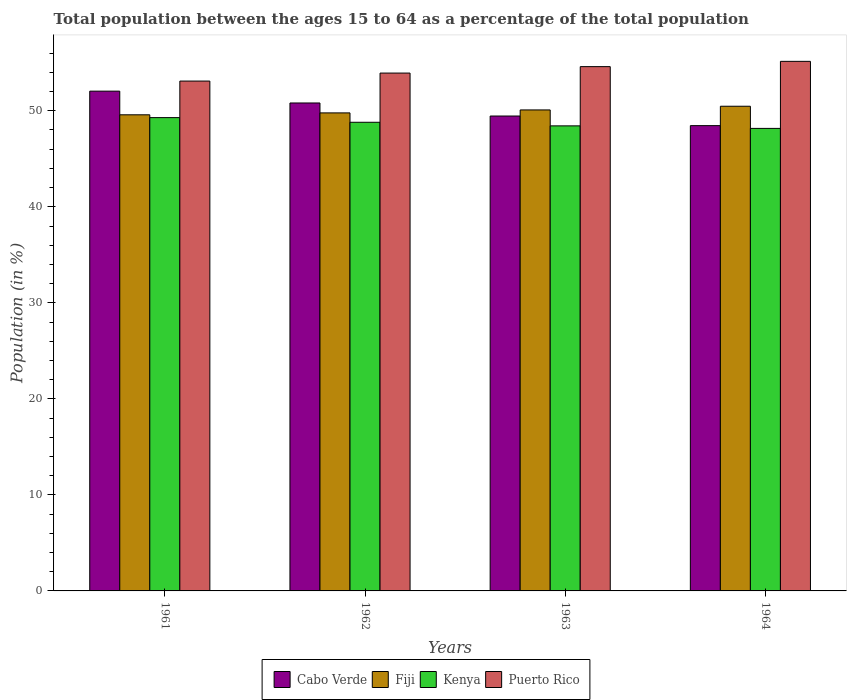Are the number of bars on each tick of the X-axis equal?
Keep it short and to the point. Yes. How many bars are there on the 3rd tick from the left?
Your answer should be compact. 4. How many bars are there on the 4th tick from the right?
Give a very brief answer. 4. What is the label of the 2nd group of bars from the left?
Ensure brevity in your answer.  1962. In how many cases, is the number of bars for a given year not equal to the number of legend labels?
Your response must be concise. 0. What is the percentage of the population ages 15 to 64 in Kenya in 1963?
Make the answer very short. 48.43. Across all years, what is the maximum percentage of the population ages 15 to 64 in Fiji?
Provide a succinct answer. 50.47. Across all years, what is the minimum percentage of the population ages 15 to 64 in Fiji?
Ensure brevity in your answer.  49.58. In which year was the percentage of the population ages 15 to 64 in Kenya maximum?
Your response must be concise. 1961. In which year was the percentage of the population ages 15 to 64 in Puerto Rico minimum?
Give a very brief answer. 1961. What is the total percentage of the population ages 15 to 64 in Cabo Verde in the graph?
Offer a very short reply. 200.76. What is the difference between the percentage of the population ages 15 to 64 in Fiji in 1961 and that in 1963?
Ensure brevity in your answer.  -0.51. What is the difference between the percentage of the population ages 15 to 64 in Cabo Verde in 1963 and the percentage of the population ages 15 to 64 in Fiji in 1964?
Offer a very short reply. -1.02. What is the average percentage of the population ages 15 to 64 in Puerto Rico per year?
Ensure brevity in your answer.  54.19. In the year 1962, what is the difference between the percentage of the population ages 15 to 64 in Kenya and percentage of the population ages 15 to 64 in Puerto Rico?
Give a very brief answer. -5.12. In how many years, is the percentage of the population ages 15 to 64 in Kenya greater than 20?
Your response must be concise. 4. What is the ratio of the percentage of the population ages 15 to 64 in Kenya in 1961 to that in 1962?
Your answer should be compact. 1.01. Is the difference between the percentage of the population ages 15 to 64 in Kenya in 1963 and 1964 greater than the difference between the percentage of the population ages 15 to 64 in Puerto Rico in 1963 and 1964?
Provide a short and direct response. Yes. What is the difference between the highest and the second highest percentage of the population ages 15 to 64 in Kenya?
Your answer should be very brief. 0.49. What is the difference between the highest and the lowest percentage of the population ages 15 to 64 in Cabo Verde?
Your answer should be very brief. 3.59. In how many years, is the percentage of the population ages 15 to 64 in Cabo Verde greater than the average percentage of the population ages 15 to 64 in Cabo Verde taken over all years?
Your answer should be very brief. 2. Is it the case that in every year, the sum of the percentage of the population ages 15 to 64 in Fiji and percentage of the population ages 15 to 64 in Cabo Verde is greater than the sum of percentage of the population ages 15 to 64 in Puerto Rico and percentage of the population ages 15 to 64 in Kenya?
Make the answer very short. No. What does the 2nd bar from the left in 1961 represents?
Give a very brief answer. Fiji. What does the 2nd bar from the right in 1961 represents?
Offer a terse response. Kenya. What is the difference between two consecutive major ticks on the Y-axis?
Your response must be concise. 10. Are the values on the major ticks of Y-axis written in scientific E-notation?
Provide a short and direct response. No. Does the graph contain any zero values?
Offer a terse response. No. Does the graph contain grids?
Make the answer very short. No. Where does the legend appear in the graph?
Your answer should be very brief. Bottom center. What is the title of the graph?
Make the answer very short. Total population between the ages 15 to 64 as a percentage of the total population. What is the Population (in %) of Cabo Verde in 1961?
Your answer should be compact. 52.04. What is the Population (in %) of Fiji in 1961?
Give a very brief answer. 49.58. What is the Population (in %) in Kenya in 1961?
Your response must be concise. 49.29. What is the Population (in %) of Puerto Rico in 1961?
Your answer should be compact. 53.09. What is the Population (in %) of Cabo Verde in 1962?
Provide a succinct answer. 50.81. What is the Population (in %) of Fiji in 1962?
Keep it short and to the point. 49.78. What is the Population (in %) in Kenya in 1962?
Make the answer very short. 48.8. What is the Population (in %) in Puerto Rico in 1962?
Provide a succinct answer. 53.93. What is the Population (in %) in Cabo Verde in 1963?
Offer a very short reply. 49.45. What is the Population (in %) of Fiji in 1963?
Your answer should be compact. 50.09. What is the Population (in %) of Kenya in 1963?
Provide a succinct answer. 48.43. What is the Population (in %) in Puerto Rico in 1963?
Your response must be concise. 54.6. What is the Population (in %) in Cabo Verde in 1964?
Your answer should be compact. 48.45. What is the Population (in %) of Fiji in 1964?
Your answer should be very brief. 50.47. What is the Population (in %) in Kenya in 1964?
Provide a short and direct response. 48.17. What is the Population (in %) in Puerto Rico in 1964?
Provide a short and direct response. 55.15. Across all years, what is the maximum Population (in %) of Cabo Verde?
Make the answer very short. 52.04. Across all years, what is the maximum Population (in %) in Fiji?
Keep it short and to the point. 50.47. Across all years, what is the maximum Population (in %) of Kenya?
Offer a terse response. 49.29. Across all years, what is the maximum Population (in %) of Puerto Rico?
Give a very brief answer. 55.15. Across all years, what is the minimum Population (in %) of Cabo Verde?
Keep it short and to the point. 48.45. Across all years, what is the minimum Population (in %) in Fiji?
Your response must be concise. 49.58. Across all years, what is the minimum Population (in %) of Kenya?
Make the answer very short. 48.17. Across all years, what is the minimum Population (in %) in Puerto Rico?
Provide a succinct answer. 53.09. What is the total Population (in %) in Cabo Verde in the graph?
Provide a succinct answer. 200.76. What is the total Population (in %) in Fiji in the graph?
Make the answer very short. 199.92. What is the total Population (in %) in Kenya in the graph?
Provide a short and direct response. 194.68. What is the total Population (in %) in Puerto Rico in the graph?
Provide a succinct answer. 216.76. What is the difference between the Population (in %) of Cabo Verde in 1961 and that in 1962?
Offer a terse response. 1.23. What is the difference between the Population (in %) of Fiji in 1961 and that in 1962?
Your response must be concise. -0.2. What is the difference between the Population (in %) in Kenya in 1961 and that in 1962?
Offer a terse response. 0.49. What is the difference between the Population (in %) of Puerto Rico in 1961 and that in 1962?
Ensure brevity in your answer.  -0.83. What is the difference between the Population (in %) in Cabo Verde in 1961 and that in 1963?
Your answer should be very brief. 2.59. What is the difference between the Population (in %) in Fiji in 1961 and that in 1963?
Your response must be concise. -0.51. What is the difference between the Population (in %) of Kenya in 1961 and that in 1963?
Give a very brief answer. 0.86. What is the difference between the Population (in %) in Puerto Rico in 1961 and that in 1963?
Provide a succinct answer. -1.5. What is the difference between the Population (in %) in Cabo Verde in 1961 and that in 1964?
Offer a very short reply. 3.59. What is the difference between the Population (in %) of Fiji in 1961 and that in 1964?
Offer a terse response. -0.89. What is the difference between the Population (in %) of Kenya in 1961 and that in 1964?
Your response must be concise. 1.12. What is the difference between the Population (in %) of Puerto Rico in 1961 and that in 1964?
Offer a terse response. -2.05. What is the difference between the Population (in %) in Cabo Verde in 1962 and that in 1963?
Offer a very short reply. 1.36. What is the difference between the Population (in %) of Fiji in 1962 and that in 1963?
Your response must be concise. -0.31. What is the difference between the Population (in %) of Kenya in 1962 and that in 1963?
Keep it short and to the point. 0.37. What is the difference between the Population (in %) in Puerto Rico in 1962 and that in 1963?
Your response must be concise. -0.67. What is the difference between the Population (in %) in Cabo Verde in 1962 and that in 1964?
Keep it short and to the point. 2.36. What is the difference between the Population (in %) of Fiji in 1962 and that in 1964?
Give a very brief answer. -0.69. What is the difference between the Population (in %) in Kenya in 1962 and that in 1964?
Keep it short and to the point. 0.64. What is the difference between the Population (in %) of Puerto Rico in 1962 and that in 1964?
Keep it short and to the point. -1.22. What is the difference between the Population (in %) of Fiji in 1963 and that in 1964?
Offer a terse response. -0.38. What is the difference between the Population (in %) of Kenya in 1963 and that in 1964?
Keep it short and to the point. 0.26. What is the difference between the Population (in %) of Puerto Rico in 1963 and that in 1964?
Your answer should be very brief. -0.55. What is the difference between the Population (in %) of Cabo Verde in 1961 and the Population (in %) of Fiji in 1962?
Your answer should be compact. 2.27. What is the difference between the Population (in %) of Cabo Verde in 1961 and the Population (in %) of Kenya in 1962?
Your answer should be compact. 3.24. What is the difference between the Population (in %) in Cabo Verde in 1961 and the Population (in %) in Puerto Rico in 1962?
Your answer should be very brief. -1.88. What is the difference between the Population (in %) in Fiji in 1961 and the Population (in %) in Kenya in 1962?
Give a very brief answer. 0.78. What is the difference between the Population (in %) of Fiji in 1961 and the Population (in %) of Puerto Rico in 1962?
Your answer should be very brief. -4.35. What is the difference between the Population (in %) in Kenya in 1961 and the Population (in %) in Puerto Rico in 1962?
Your answer should be very brief. -4.64. What is the difference between the Population (in %) in Cabo Verde in 1961 and the Population (in %) in Fiji in 1963?
Keep it short and to the point. 1.96. What is the difference between the Population (in %) in Cabo Verde in 1961 and the Population (in %) in Kenya in 1963?
Make the answer very short. 3.62. What is the difference between the Population (in %) in Cabo Verde in 1961 and the Population (in %) in Puerto Rico in 1963?
Give a very brief answer. -2.55. What is the difference between the Population (in %) in Fiji in 1961 and the Population (in %) in Kenya in 1963?
Ensure brevity in your answer.  1.15. What is the difference between the Population (in %) of Fiji in 1961 and the Population (in %) of Puerto Rico in 1963?
Your answer should be compact. -5.02. What is the difference between the Population (in %) of Kenya in 1961 and the Population (in %) of Puerto Rico in 1963?
Offer a terse response. -5.31. What is the difference between the Population (in %) of Cabo Verde in 1961 and the Population (in %) of Fiji in 1964?
Make the answer very short. 1.57. What is the difference between the Population (in %) in Cabo Verde in 1961 and the Population (in %) in Kenya in 1964?
Offer a very short reply. 3.88. What is the difference between the Population (in %) in Cabo Verde in 1961 and the Population (in %) in Puerto Rico in 1964?
Keep it short and to the point. -3.1. What is the difference between the Population (in %) in Fiji in 1961 and the Population (in %) in Kenya in 1964?
Give a very brief answer. 1.42. What is the difference between the Population (in %) of Fiji in 1961 and the Population (in %) of Puerto Rico in 1964?
Offer a terse response. -5.57. What is the difference between the Population (in %) of Kenya in 1961 and the Population (in %) of Puerto Rico in 1964?
Ensure brevity in your answer.  -5.86. What is the difference between the Population (in %) in Cabo Verde in 1962 and the Population (in %) in Fiji in 1963?
Give a very brief answer. 0.72. What is the difference between the Population (in %) of Cabo Verde in 1962 and the Population (in %) of Kenya in 1963?
Provide a short and direct response. 2.38. What is the difference between the Population (in %) of Cabo Verde in 1962 and the Population (in %) of Puerto Rico in 1963?
Your response must be concise. -3.78. What is the difference between the Population (in %) in Fiji in 1962 and the Population (in %) in Kenya in 1963?
Your answer should be compact. 1.35. What is the difference between the Population (in %) of Fiji in 1962 and the Population (in %) of Puerto Rico in 1963?
Your answer should be very brief. -4.82. What is the difference between the Population (in %) of Kenya in 1962 and the Population (in %) of Puerto Rico in 1963?
Provide a short and direct response. -5.79. What is the difference between the Population (in %) in Cabo Verde in 1962 and the Population (in %) in Fiji in 1964?
Your answer should be compact. 0.34. What is the difference between the Population (in %) in Cabo Verde in 1962 and the Population (in %) in Kenya in 1964?
Provide a short and direct response. 2.65. What is the difference between the Population (in %) in Cabo Verde in 1962 and the Population (in %) in Puerto Rico in 1964?
Provide a succinct answer. -4.33. What is the difference between the Population (in %) of Fiji in 1962 and the Population (in %) of Kenya in 1964?
Offer a very short reply. 1.61. What is the difference between the Population (in %) of Fiji in 1962 and the Population (in %) of Puerto Rico in 1964?
Offer a very short reply. -5.37. What is the difference between the Population (in %) of Kenya in 1962 and the Population (in %) of Puerto Rico in 1964?
Provide a succinct answer. -6.34. What is the difference between the Population (in %) of Cabo Verde in 1963 and the Population (in %) of Fiji in 1964?
Ensure brevity in your answer.  -1.02. What is the difference between the Population (in %) in Cabo Verde in 1963 and the Population (in %) in Kenya in 1964?
Offer a terse response. 1.29. What is the difference between the Population (in %) of Cabo Verde in 1963 and the Population (in %) of Puerto Rico in 1964?
Keep it short and to the point. -5.69. What is the difference between the Population (in %) in Fiji in 1963 and the Population (in %) in Kenya in 1964?
Offer a very short reply. 1.92. What is the difference between the Population (in %) of Fiji in 1963 and the Population (in %) of Puerto Rico in 1964?
Provide a short and direct response. -5.06. What is the difference between the Population (in %) in Kenya in 1963 and the Population (in %) in Puerto Rico in 1964?
Provide a short and direct response. -6.72. What is the average Population (in %) of Cabo Verde per year?
Offer a very short reply. 50.19. What is the average Population (in %) in Fiji per year?
Your answer should be compact. 49.98. What is the average Population (in %) of Kenya per year?
Make the answer very short. 48.67. What is the average Population (in %) in Puerto Rico per year?
Offer a terse response. 54.19. In the year 1961, what is the difference between the Population (in %) of Cabo Verde and Population (in %) of Fiji?
Offer a terse response. 2.46. In the year 1961, what is the difference between the Population (in %) in Cabo Verde and Population (in %) in Kenya?
Provide a short and direct response. 2.76. In the year 1961, what is the difference between the Population (in %) in Cabo Verde and Population (in %) in Puerto Rico?
Keep it short and to the point. -1.05. In the year 1961, what is the difference between the Population (in %) in Fiji and Population (in %) in Kenya?
Offer a very short reply. 0.29. In the year 1961, what is the difference between the Population (in %) of Fiji and Population (in %) of Puerto Rico?
Ensure brevity in your answer.  -3.51. In the year 1961, what is the difference between the Population (in %) of Kenya and Population (in %) of Puerto Rico?
Offer a very short reply. -3.81. In the year 1962, what is the difference between the Population (in %) in Cabo Verde and Population (in %) in Fiji?
Offer a terse response. 1.03. In the year 1962, what is the difference between the Population (in %) in Cabo Verde and Population (in %) in Kenya?
Offer a terse response. 2.01. In the year 1962, what is the difference between the Population (in %) of Cabo Verde and Population (in %) of Puerto Rico?
Your response must be concise. -3.11. In the year 1962, what is the difference between the Population (in %) of Fiji and Population (in %) of Kenya?
Provide a short and direct response. 0.98. In the year 1962, what is the difference between the Population (in %) of Fiji and Population (in %) of Puerto Rico?
Your response must be concise. -4.15. In the year 1962, what is the difference between the Population (in %) in Kenya and Population (in %) in Puerto Rico?
Provide a short and direct response. -5.12. In the year 1963, what is the difference between the Population (in %) of Cabo Verde and Population (in %) of Fiji?
Keep it short and to the point. -0.63. In the year 1963, what is the difference between the Population (in %) of Cabo Verde and Population (in %) of Kenya?
Offer a very short reply. 1.03. In the year 1963, what is the difference between the Population (in %) in Cabo Verde and Population (in %) in Puerto Rico?
Ensure brevity in your answer.  -5.14. In the year 1963, what is the difference between the Population (in %) in Fiji and Population (in %) in Kenya?
Offer a terse response. 1.66. In the year 1963, what is the difference between the Population (in %) of Fiji and Population (in %) of Puerto Rico?
Keep it short and to the point. -4.51. In the year 1963, what is the difference between the Population (in %) of Kenya and Population (in %) of Puerto Rico?
Your response must be concise. -6.17. In the year 1964, what is the difference between the Population (in %) of Cabo Verde and Population (in %) of Fiji?
Give a very brief answer. -2.02. In the year 1964, what is the difference between the Population (in %) of Cabo Verde and Population (in %) of Kenya?
Provide a short and direct response. 0.29. In the year 1964, what is the difference between the Population (in %) of Cabo Verde and Population (in %) of Puerto Rico?
Your answer should be very brief. -6.69. In the year 1964, what is the difference between the Population (in %) of Fiji and Population (in %) of Kenya?
Provide a short and direct response. 2.31. In the year 1964, what is the difference between the Population (in %) in Fiji and Population (in %) in Puerto Rico?
Your answer should be very brief. -4.67. In the year 1964, what is the difference between the Population (in %) in Kenya and Population (in %) in Puerto Rico?
Provide a succinct answer. -6.98. What is the ratio of the Population (in %) of Cabo Verde in 1961 to that in 1962?
Give a very brief answer. 1.02. What is the ratio of the Population (in %) of Kenya in 1961 to that in 1962?
Provide a succinct answer. 1.01. What is the ratio of the Population (in %) in Puerto Rico in 1961 to that in 1962?
Give a very brief answer. 0.98. What is the ratio of the Population (in %) in Cabo Verde in 1961 to that in 1963?
Provide a succinct answer. 1.05. What is the ratio of the Population (in %) of Kenya in 1961 to that in 1963?
Offer a terse response. 1.02. What is the ratio of the Population (in %) in Puerto Rico in 1961 to that in 1963?
Provide a short and direct response. 0.97. What is the ratio of the Population (in %) of Cabo Verde in 1961 to that in 1964?
Provide a succinct answer. 1.07. What is the ratio of the Population (in %) of Fiji in 1961 to that in 1964?
Offer a very short reply. 0.98. What is the ratio of the Population (in %) in Kenya in 1961 to that in 1964?
Ensure brevity in your answer.  1.02. What is the ratio of the Population (in %) of Puerto Rico in 1961 to that in 1964?
Make the answer very short. 0.96. What is the ratio of the Population (in %) of Cabo Verde in 1962 to that in 1963?
Your response must be concise. 1.03. What is the ratio of the Population (in %) in Fiji in 1962 to that in 1963?
Your answer should be compact. 0.99. What is the ratio of the Population (in %) in Kenya in 1962 to that in 1963?
Ensure brevity in your answer.  1.01. What is the ratio of the Population (in %) in Puerto Rico in 1962 to that in 1963?
Ensure brevity in your answer.  0.99. What is the ratio of the Population (in %) in Cabo Verde in 1962 to that in 1964?
Your answer should be compact. 1.05. What is the ratio of the Population (in %) in Fiji in 1962 to that in 1964?
Provide a short and direct response. 0.99. What is the ratio of the Population (in %) of Kenya in 1962 to that in 1964?
Ensure brevity in your answer.  1.01. What is the ratio of the Population (in %) in Puerto Rico in 1962 to that in 1964?
Your response must be concise. 0.98. What is the ratio of the Population (in %) in Cabo Verde in 1963 to that in 1964?
Your answer should be very brief. 1.02. What is the ratio of the Population (in %) in Fiji in 1963 to that in 1964?
Provide a short and direct response. 0.99. What is the ratio of the Population (in %) of Kenya in 1963 to that in 1964?
Provide a succinct answer. 1.01. What is the difference between the highest and the second highest Population (in %) in Cabo Verde?
Your response must be concise. 1.23. What is the difference between the highest and the second highest Population (in %) in Fiji?
Provide a short and direct response. 0.38. What is the difference between the highest and the second highest Population (in %) in Kenya?
Make the answer very short. 0.49. What is the difference between the highest and the second highest Population (in %) in Puerto Rico?
Provide a succinct answer. 0.55. What is the difference between the highest and the lowest Population (in %) in Cabo Verde?
Make the answer very short. 3.59. What is the difference between the highest and the lowest Population (in %) of Fiji?
Give a very brief answer. 0.89. What is the difference between the highest and the lowest Population (in %) in Kenya?
Offer a terse response. 1.12. What is the difference between the highest and the lowest Population (in %) in Puerto Rico?
Your answer should be compact. 2.05. 